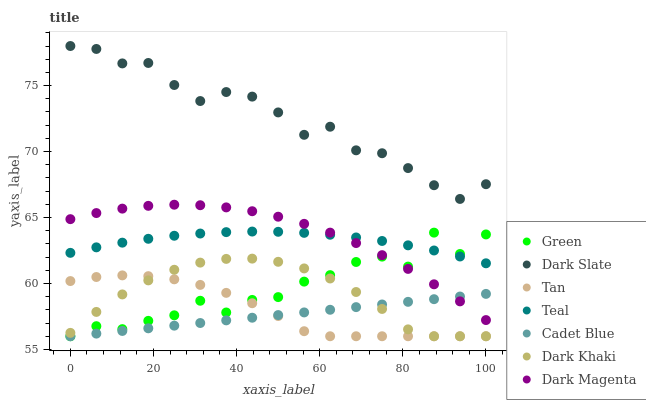Does Cadet Blue have the minimum area under the curve?
Answer yes or no. Yes. Does Dark Slate have the maximum area under the curve?
Answer yes or no. Yes. Does Dark Magenta have the minimum area under the curve?
Answer yes or no. No. Does Dark Magenta have the maximum area under the curve?
Answer yes or no. No. Is Cadet Blue the smoothest?
Answer yes or no. Yes. Is Green the roughest?
Answer yes or no. Yes. Is Dark Magenta the smoothest?
Answer yes or no. No. Is Dark Magenta the roughest?
Answer yes or no. No. Does Cadet Blue have the lowest value?
Answer yes or no. Yes. Does Dark Magenta have the lowest value?
Answer yes or no. No. Does Dark Slate have the highest value?
Answer yes or no. Yes. Does Dark Magenta have the highest value?
Answer yes or no. No. Is Tan less than Dark Slate?
Answer yes or no. Yes. Is Dark Slate greater than Teal?
Answer yes or no. Yes. Does Cadet Blue intersect Green?
Answer yes or no. Yes. Is Cadet Blue less than Green?
Answer yes or no. No. Is Cadet Blue greater than Green?
Answer yes or no. No. Does Tan intersect Dark Slate?
Answer yes or no. No. 